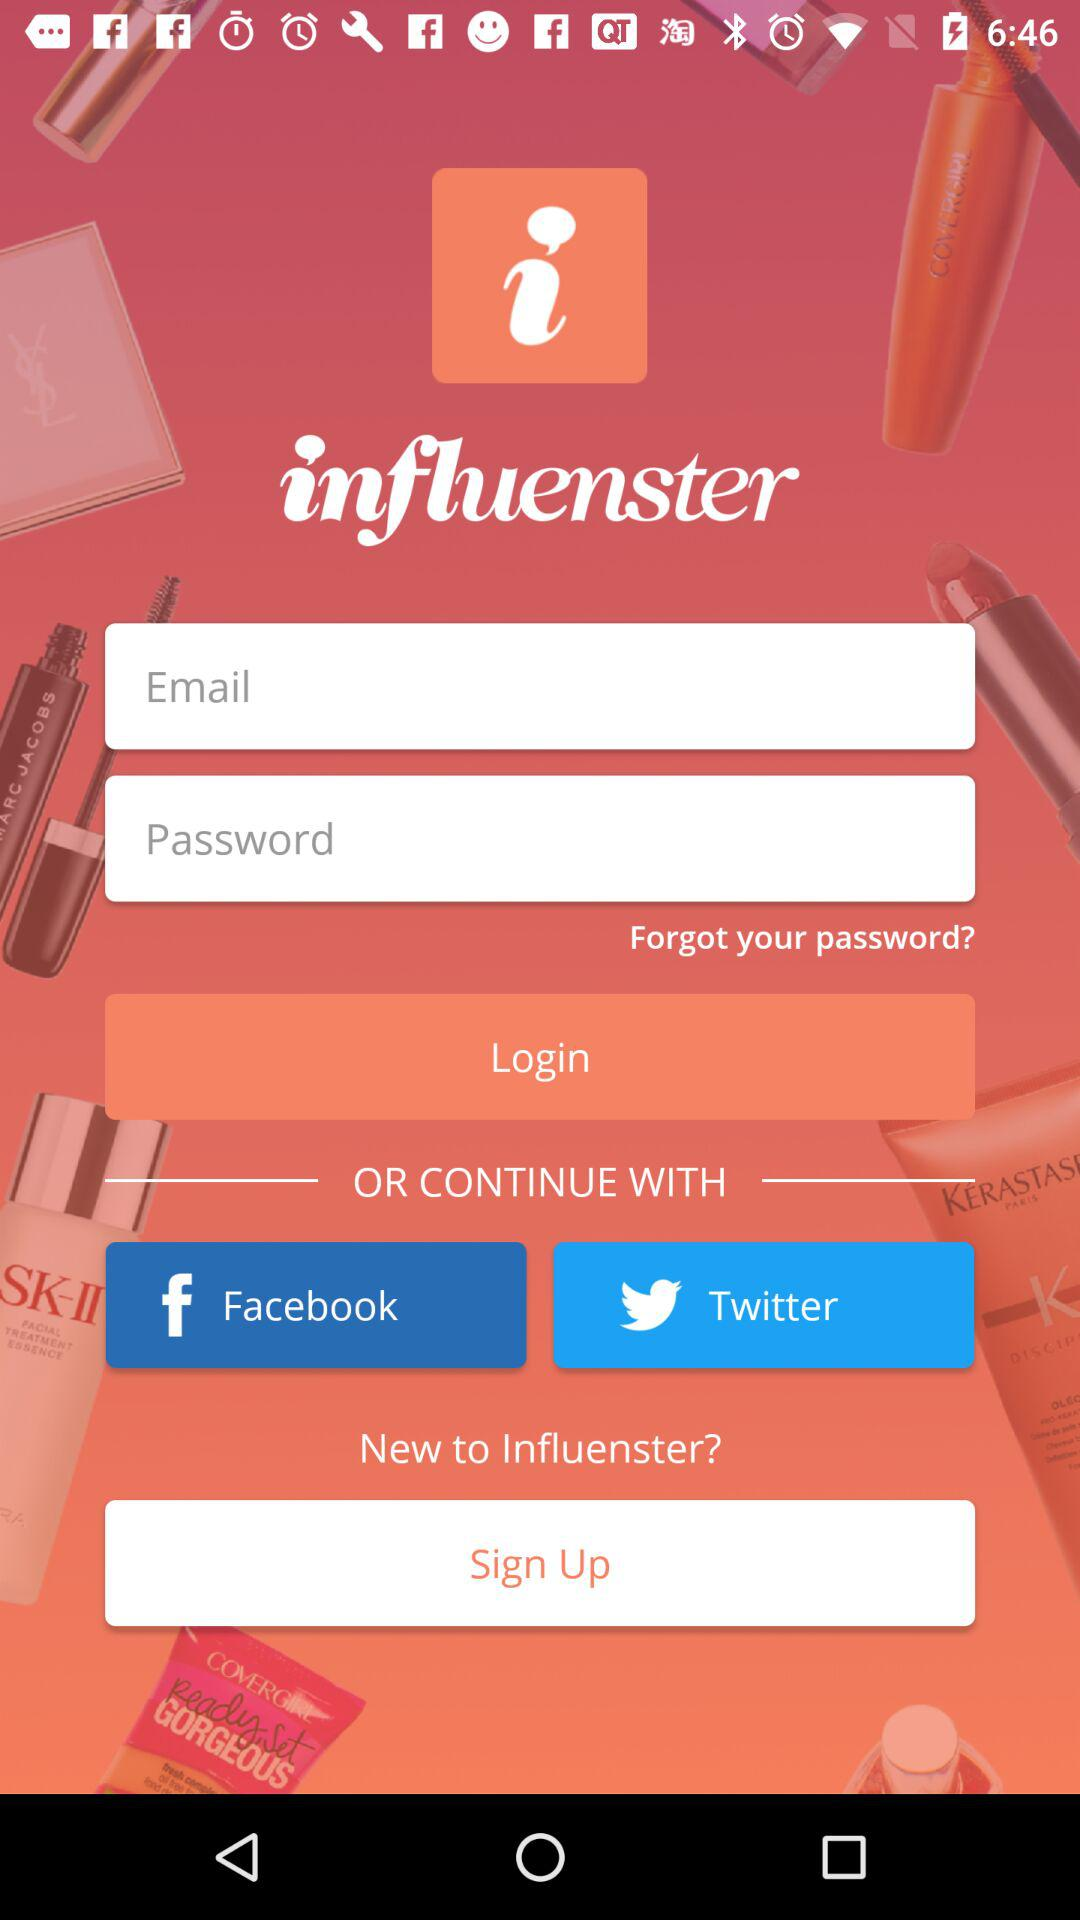What is the name of the application? The application name is "influenster". 